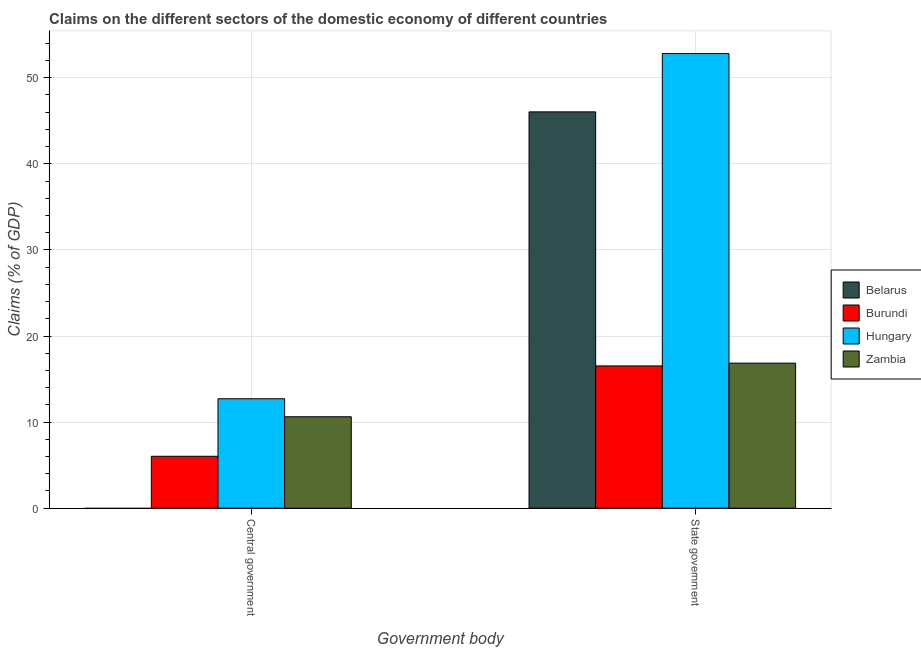How many different coloured bars are there?
Keep it short and to the point. 4. Are the number of bars on each tick of the X-axis equal?
Keep it short and to the point. No. What is the label of the 2nd group of bars from the left?
Provide a short and direct response. State government. What is the claims on state government in Zambia?
Provide a succinct answer. 16.85. Across all countries, what is the maximum claims on central government?
Offer a very short reply. 12.71. Across all countries, what is the minimum claims on central government?
Your answer should be compact. 0. In which country was the claims on central government maximum?
Your answer should be compact. Hungary. What is the total claims on central government in the graph?
Keep it short and to the point. 29.36. What is the difference between the claims on state government in Hungary and that in Burundi?
Provide a succinct answer. 36.28. What is the difference between the claims on state government in Zambia and the claims on central government in Belarus?
Ensure brevity in your answer.  16.85. What is the average claims on state government per country?
Ensure brevity in your answer.  33.05. What is the difference between the claims on central government and claims on state government in Burundi?
Provide a short and direct response. -10.49. In how many countries, is the claims on central government greater than 42 %?
Your response must be concise. 0. What is the ratio of the claims on state government in Belarus to that in Zambia?
Make the answer very short. 2.73. Is the claims on central government in Zambia less than that in Hungary?
Ensure brevity in your answer.  Yes. In how many countries, is the claims on central government greater than the average claims on central government taken over all countries?
Give a very brief answer. 2. Are all the bars in the graph horizontal?
Offer a very short reply. No. Are the values on the major ticks of Y-axis written in scientific E-notation?
Give a very brief answer. No. Does the graph contain any zero values?
Provide a succinct answer. Yes. Does the graph contain grids?
Your answer should be very brief. Yes. How many legend labels are there?
Provide a short and direct response. 4. How are the legend labels stacked?
Keep it short and to the point. Vertical. What is the title of the graph?
Give a very brief answer. Claims on the different sectors of the domestic economy of different countries. Does "Bhutan" appear as one of the legend labels in the graph?
Provide a succinct answer. No. What is the label or title of the X-axis?
Your answer should be very brief. Government body. What is the label or title of the Y-axis?
Keep it short and to the point. Claims (% of GDP). What is the Claims (% of GDP) in Belarus in Central government?
Keep it short and to the point. 0. What is the Claims (% of GDP) in Burundi in Central government?
Provide a succinct answer. 6.03. What is the Claims (% of GDP) in Hungary in Central government?
Give a very brief answer. 12.71. What is the Claims (% of GDP) in Zambia in Central government?
Give a very brief answer. 10.62. What is the Claims (% of GDP) in Belarus in State government?
Make the answer very short. 46.03. What is the Claims (% of GDP) of Burundi in State government?
Give a very brief answer. 16.52. What is the Claims (% of GDP) in Hungary in State government?
Your answer should be very brief. 52.81. What is the Claims (% of GDP) of Zambia in State government?
Keep it short and to the point. 16.85. Across all Government body, what is the maximum Claims (% of GDP) in Belarus?
Keep it short and to the point. 46.03. Across all Government body, what is the maximum Claims (% of GDP) of Burundi?
Make the answer very short. 16.52. Across all Government body, what is the maximum Claims (% of GDP) of Hungary?
Keep it short and to the point. 52.81. Across all Government body, what is the maximum Claims (% of GDP) of Zambia?
Your answer should be very brief. 16.85. Across all Government body, what is the minimum Claims (% of GDP) in Burundi?
Offer a terse response. 6.03. Across all Government body, what is the minimum Claims (% of GDP) of Hungary?
Ensure brevity in your answer.  12.71. Across all Government body, what is the minimum Claims (% of GDP) in Zambia?
Provide a succinct answer. 10.62. What is the total Claims (% of GDP) in Belarus in the graph?
Offer a very short reply. 46.03. What is the total Claims (% of GDP) in Burundi in the graph?
Give a very brief answer. 22.56. What is the total Claims (% of GDP) in Hungary in the graph?
Your answer should be very brief. 65.52. What is the total Claims (% of GDP) in Zambia in the graph?
Make the answer very short. 27.47. What is the difference between the Claims (% of GDP) of Burundi in Central government and that in State government?
Make the answer very short. -10.49. What is the difference between the Claims (% of GDP) in Hungary in Central government and that in State government?
Offer a very short reply. -40.1. What is the difference between the Claims (% of GDP) of Zambia in Central government and that in State government?
Offer a very short reply. -6.23. What is the difference between the Claims (% of GDP) of Burundi in Central government and the Claims (% of GDP) of Hungary in State government?
Give a very brief answer. -46.78. What is the difference between the Claims (% of GDP) of Burundi in Central government and the Claims (% of GDP) of Zambia in State government?
Your answer should be very brief. -10.82. What is the difference between the Claims (% of GDP) in Hungary in Central government and the Claims (% of GDP) in Zambia in State government?
Keep it short and to the point. -4.14. What is the average Claims (% of GDP) in Belarus per Government body?
Your answer should be very brief. 23.02. What is the average Claims (% of GDP) in Burundi per Government body?
Give a very brief answer. 11.28. What is the average Claims (% of GDP) of Hungary per Government body?
Provide a succinct answer. 32.76. What is the average Claims (% of GDP) of Zambia per Government body?
Give a very brief answer. 13.73. What is the difference between the Claims (% of GDP) in Burundi and Claims (% of GDP) in Hungary in Central government?
Keep it short and to the point. -6.68. What is the difference between the Claims (% of GDP) of Burundi and Claims (% of GDP) of Zambia in Central government?
Provide a short and direct response. -4.59. What is the difference between the Claims (% of GDP) of Hungary and Claims (% of GDP) of Zambia in Central government?
Offer a very short reply. 2.09. What is the difference between the Claims (% of GDP) in Belarus and Claims (% of GDP) in Burundi in State government?
Offer a very short reply. 29.51. What is the difference between the Claims (% of GDP) in Belarus and Claims (% of GDP) in Hungary in State government?
Offer a very short reply. -6.77. What is the difference between the Claims (% of GDP) in Belarus and Claims (% of GDP) in Zambia in State government?
Keep it short and to the point. 29.19. What is the difference between the Claims (% of GDP) in Burundi and Claims (% of GDP) in Hungary in State government?
Your response must be concise. -36.28. What is the difference between the Claims (% of GDP) of Burundi and Claims (% of GDP) of Zambia in State government?
Your answer should be compact. -0.32. What is the difference between the Claims (% of GDP) of Hungary and Claims (% of GDP) of Zambia in State government?
Provide a succinct answer. 35.96. What is the ratio of the Claims (% of GDP) of Burundi in Central government to that in State government?
Your response must be concise. 0.36. What is the ratio of the Claims (% of GDP) in Hungary in Central government to that in State government?
Make the answer very short. 0.24. What is the ratio of the Claims (% of GDP) of Zambia in Central government to that in State government?
Provide a short and direct response. 0.63. What is the difference between the highest and the second highest Claims (% of GDP) in Burundi?
Keep it short and to the point. 10.49. What is the difference between the highest and the second highest Claims (% of GDP) in Hungary?
Keep it short and to the point. 40.1. What is the difference between the highest and the second highest Claims (% of GDP) of Zambia?
Offer a very short reply. 6.23. What is the difference between the highest and the lowest Claims (% of GDP) of Belarus?
Provide a short and direct response. 46.03. What is the difference between the highest and the lowest Claims (% of GDP) of Burundi?
Your answer should be compact. 10.49. What is the difference between the highest and the lowest Claims (% of GDP) of Hungary?
Your answer should be compact. 40.1. What is the difference between the highest and the lowest Claims (% of GDP) in Zambia?
Make the answer very short. 6.23. 